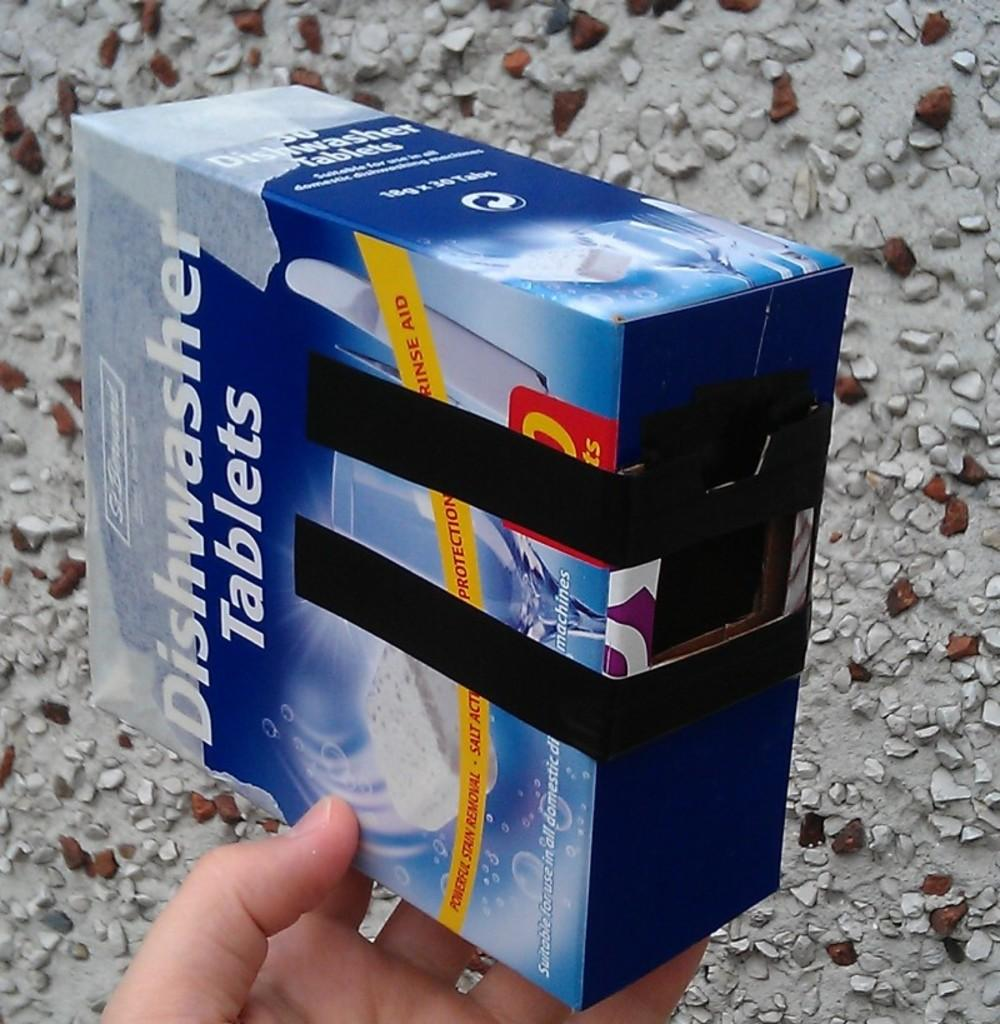<image>
Render a clear and concise summary of the photo. a box being held by someone that says 'dishwasher tablets' on it 